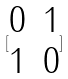<formula> <loc_0><loc_0><loc_500><loc_500>[ \begin{matrix} 0 & 1 \\ 1 & 0 \end{matrix} ]</formula> 